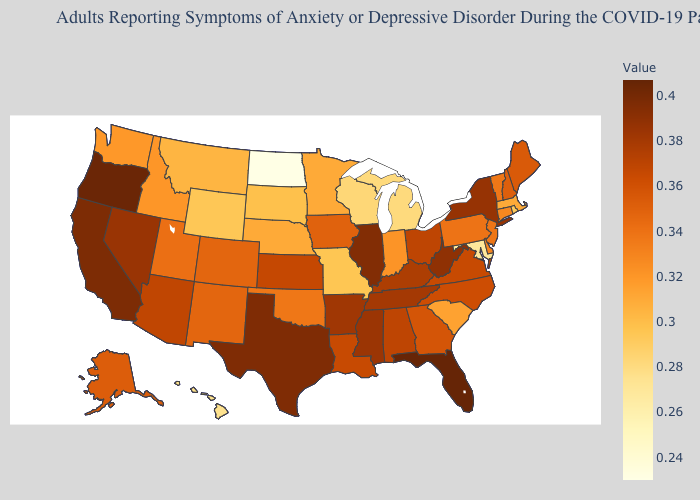Which states have the lowest value in the USA?
Write a very short answer. North Dakota. Among the states that border North Dakota , does Minnesota have the highest value?
Answer briefly. Yes. Which states hav the highest value in the West?
Quick response, please. Oregon. Does North Dakota have the lowest value in the USA?
Give a very brief answer. Yes. Does Indiana have a lower value than Alabama?
Quick response, please. Yes. Does Missouri have a lower value than North Dakota?
Give a very brief answer. No. Does Delaware have the highest value in the USA?
Keep it brief. No. 